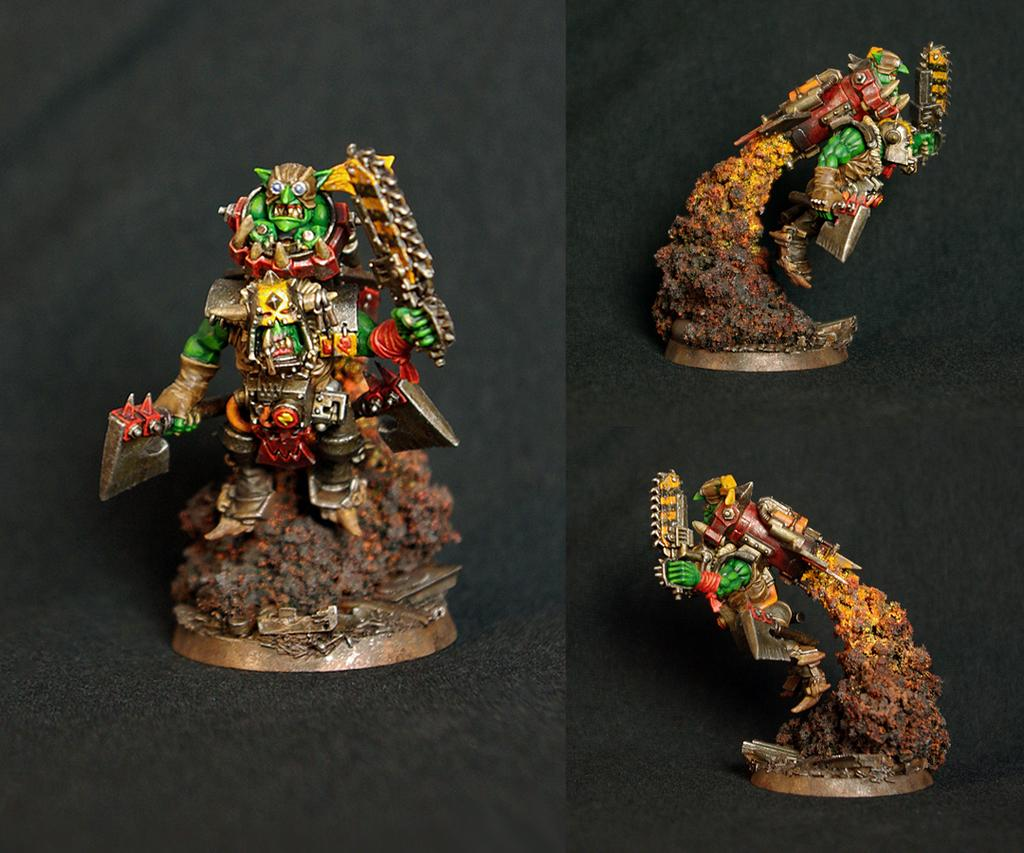What type of objects are in the image? There are miniatures in the image. How are the miniatures arranged in the image? The miniatures form a collage of two pictures. What type of appliance can be seen in the image? There is no appliance present in the image; it features miniatures arranged in a collage. What type of snack is being prepared in the image? There is no snack preparation visible in the image; it only contains miniatures arranged in a collage. 